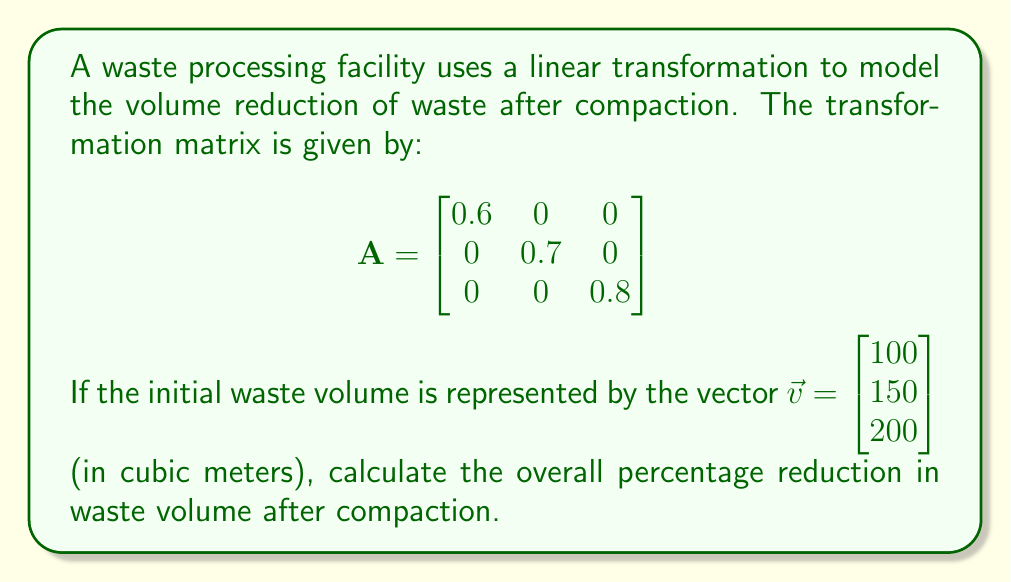Teach me how to tackle this problem. To solve this problem, we'll follow these steps:

1) Apply the linear transformation to the initial waste volume vector:
   $$A\vec{v} = \begin{bmatrix} 0.6 & 0 & 0 \\ 0 & 0.7 & 0 \\ 0 & 0 & 0.8 \end{bmatrix} \begin{bmatrix} 100 \\ 150 \\ 200 \end{bmatrix}$$

2) Perform the matrix multiplication:
   $$A\vec{v} = \begin{bmatrix} 0.6(100) \\ 0.7(150) \\ 0.8(200) \end{bmatrix} = \begin{bmatrix} 60 \\ 105 \\ 160 \end{bmatrix}$$

3) Calculate the initial total volume:
   Initial volume = $100 + 150 + 200 = 450$ cubic meters

4) Calculate the final total volume:
   Final volume = $60 + 105 + 160 = 325$ cubic meters

5) Calculate the volume reduction:
   Volume reduction = Initial volume - Final volume
                    = $450 - 325 = 125$ cubic meters

6) Calculate the percentage reduction:
   Percentage reduction = $\frac{\text{Volume reduction}}{\text{Initial volume}} \times 100\%$
                        = $\frac{125}{450} \times 100\%$
                        = $0.2777... \times 100\%$
                        ≈ $27.78\%$

Therefore, the overall percentage reduction in waste volume after compaction is approximately 27.78%.
Answer: 27.78% 